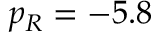<formula> <loc_0><loc_0><loc_500><loc_500>p _ { R } = - 5 . 8</formula> 